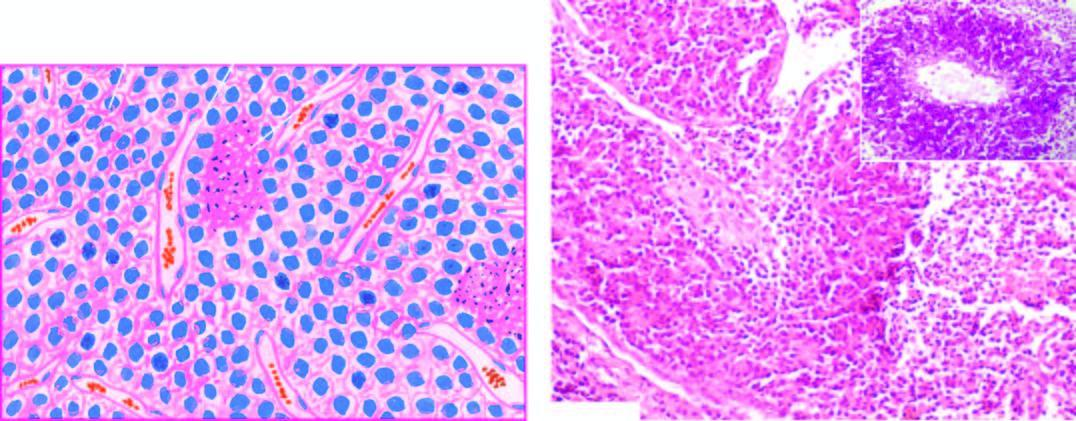what shows pas positive tumour cells in perivascular location?
Answer the question using a single word or phrase. Inbox in the right photomicrograph 